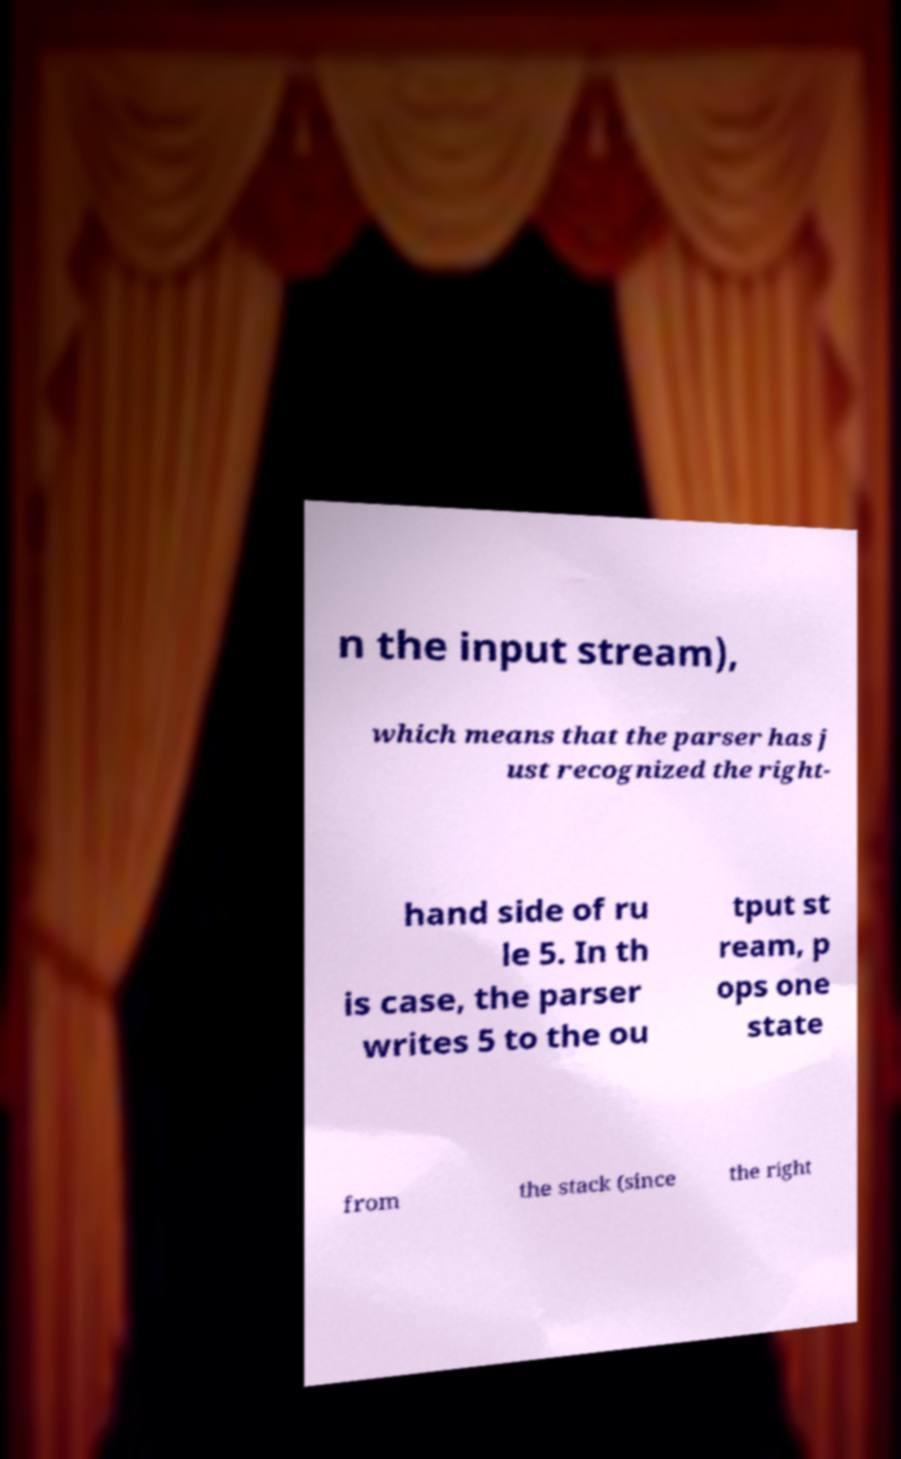Can you read and provide the text displayed in the image?This photo seems to have some interesting text. Can you extract and type it out for me? n the input stream), which means that the parser has j ust recognized the right- hand side of ru le 5. In th is case, the parser writes 5 to the ou tput st ream, p ops one state from the stack (since the right 